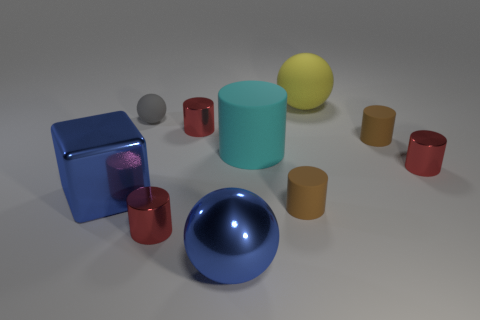Can you describe the composition of the scene? The scene contains a variety of geometric shapes, including spheres, cylinders, and cubes, arranged haphazardly on a flat surface. The objects come in different colors and materials, suggesting a study in shape and texture contrast.  What might be the purpose of this arrangement? This arrangement could be an artistic still life composition designed to study forms and colors, or it might be a set up for a lesson in geometry, demonstrating the variety of basic three-dimensional shapes. 